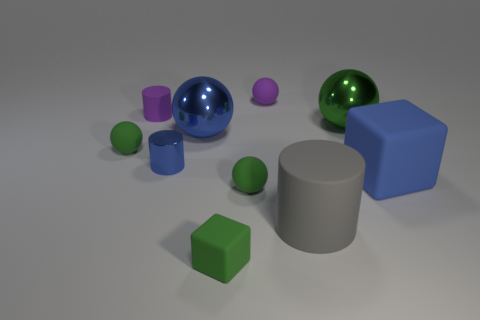Subtract all cyan cylinders. How many green balls are left? 3 Subtract all blue spheres. How many spheres are left? 4 Subtract all large blue balls. How many balls are left? 4 Subtract 3 spheres. How many spheres are left? 2 Subtract all gray spheres. Subtract all yellow blocks. How many spheres are left? 5 Subtract all large things. Subtract all purple rubber objects. How many objects are left? 4 Add 5 big shiny objects. How many big shiny objects are left? 7 Add 5 shiny things. How many shiny things exist? 8 Subtract 0 cyan cylinders. How many objects are left? 10 Subtract all blocks. How many objects are left? 8 